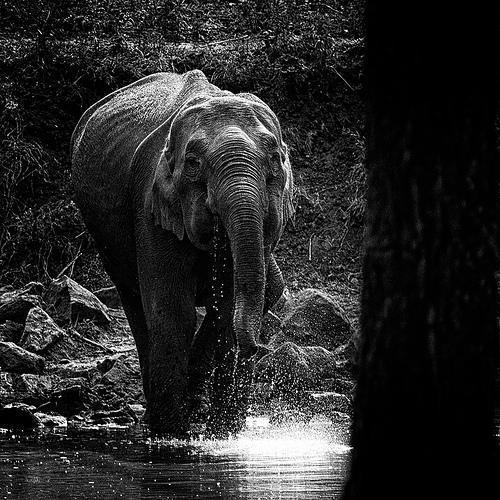How many elephants are there?
Give a very brief answer. 1. 